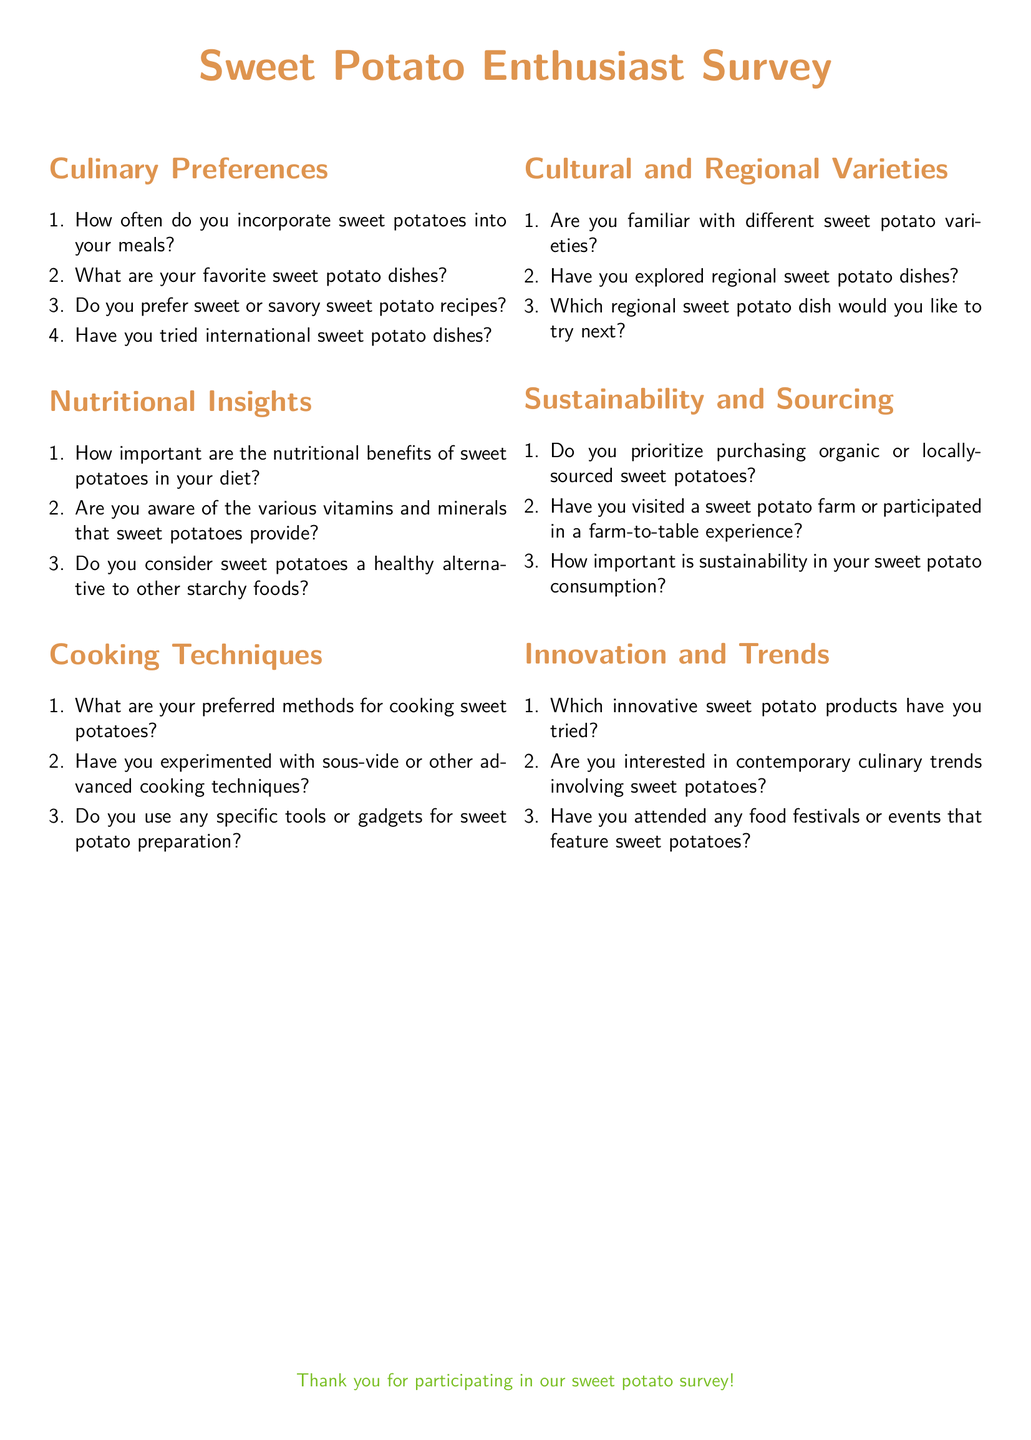How many sections are there in the questionnaire? The document has six main sections: Culinary Preferences, Nutritional Insights, Cooking Techniques, Cultural and Regional Varieties, Sustainability and Sourcing, and Innovation and Trends.
Answer: 6 What color is used for the title text? The title text is colored sweet potato, which is defined with specific RGB values in the document.
Answer: sweet potato What is the font used throughout the document? The document specifies Calibri as the main font for the text, ensuring consistency in style.
Answer: Calibri How important is sustainability in sweet potato consumption? There is a specific question regarding the importance of sustainability in sweet potato consumption in the Sustainability and Sourcing section.
Answer: Importance question What cooking methods are mentioned in the document? The Cooking Techniques section asks about preferred methods for cooking sweet potatoes without specifying them, indicating a broader inquiry.
Answer: Preferred methods Which section asks about innovative products related to sweet potatoes? The Innovation and Trends section specifically addresses innovative sweet potato products that respondents might have tried or are interested in.
Answer: Innovation and Trends Are there any questions related to the nutritional benefits of sweet potatoes? Yes, the Nutritional Insights section includes questions regarding the importance and awareness of the nutritional benefits of sweet potatoes.
Answer: Yes What type of experience does the Sustainability and Sourcing section inquire about? This section asks if participants have visited a sweet potato farm or participated in a farm-to-table experience, linking sustainability with firsthand experiences.
Answer: Farm-to-table experience 